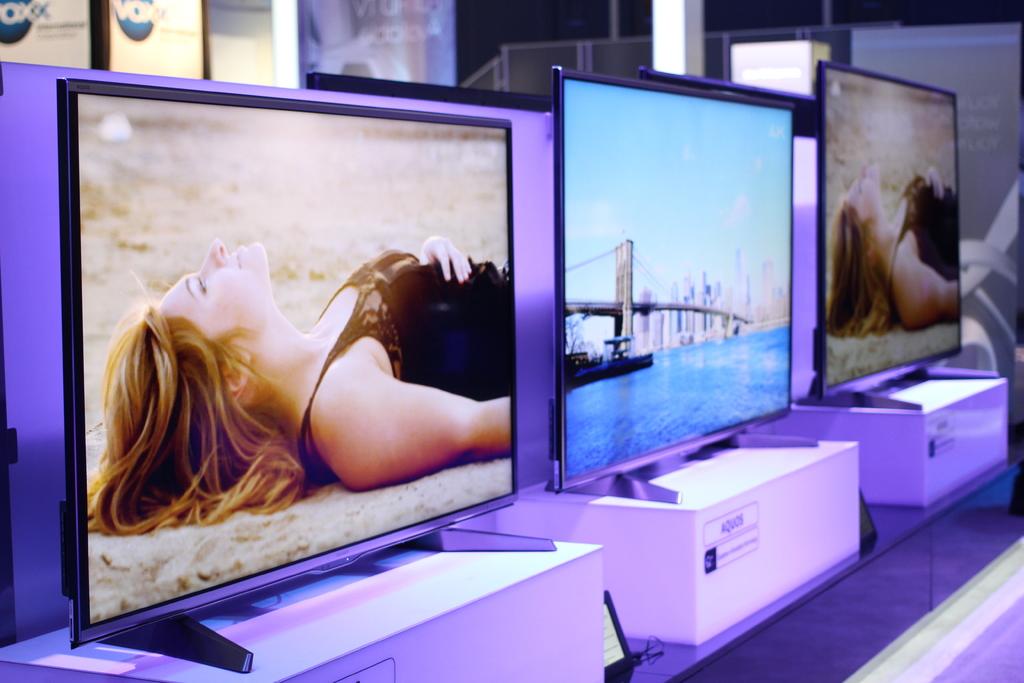What brand television is in the middle?
Your answer should be compact. Aquos. 